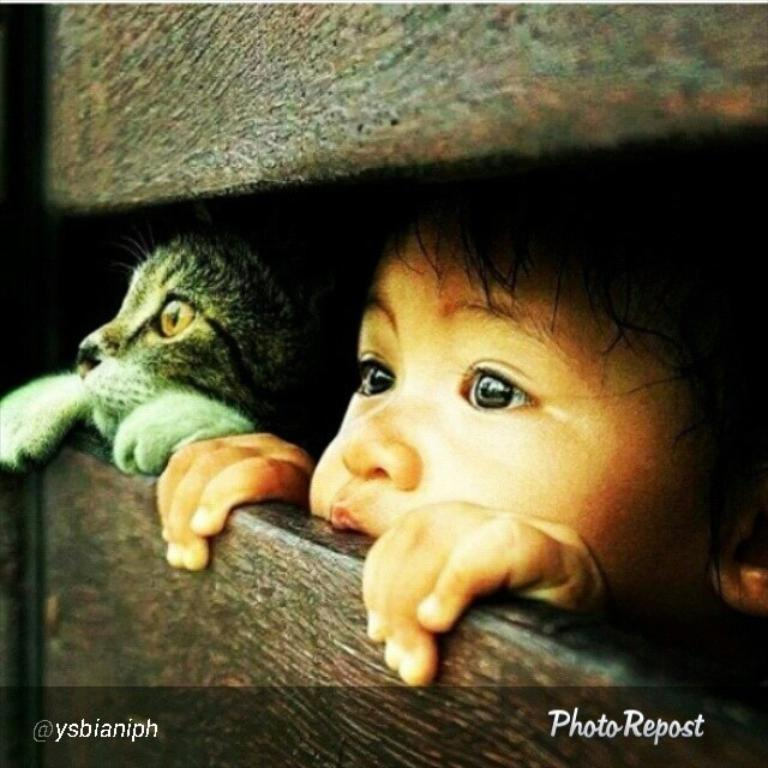What is the main subject of focus of the image? There is a person and a cat in the center of the image. Can you describe the objects in the image? Unfortunately, the provided facts do not give any information about the objects in the image. Is there any text or marking at the bottom of the image? Yes, there is a watermark at the bottom of the image. What type of soup is being prepared by the person in the image? There is no soup or any indication of food preparation in the image. What is the cat using to cut the objects in the image? There is no knife or any cutting activity in the image. 